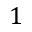Convert formula to latex. <formula><loc_0><loc_0><loc_500><loc_500>1</formula> 